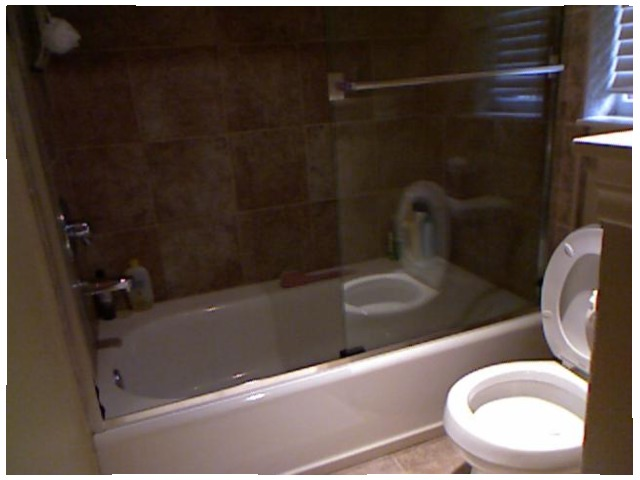<image>
Can you confirm if the toilet is under the window? Yes. The toilet is positioned underneath the window, with the window above it in the vertical space. 